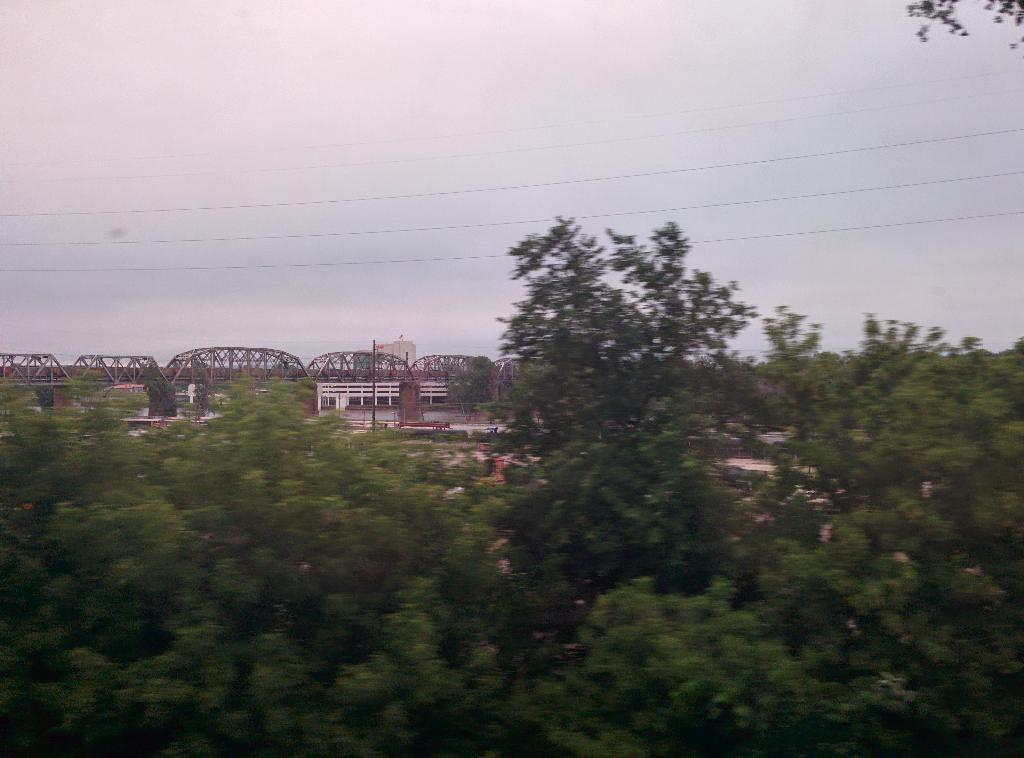What type of natural elements can be seen in the image? There are trees in the image. What man-made structure is present in the image? There is a bridge in the image. What else can be seen in the image besides trees and the bridge? There are wires in the image. What is visible in the background of the image? The sky is visible in the background of the image. How long does it take for the coach to pass under the bridge in the image? There is no coach present in the image, so it is not possible to determine how long it would take for a coach to pass under the bridge. 